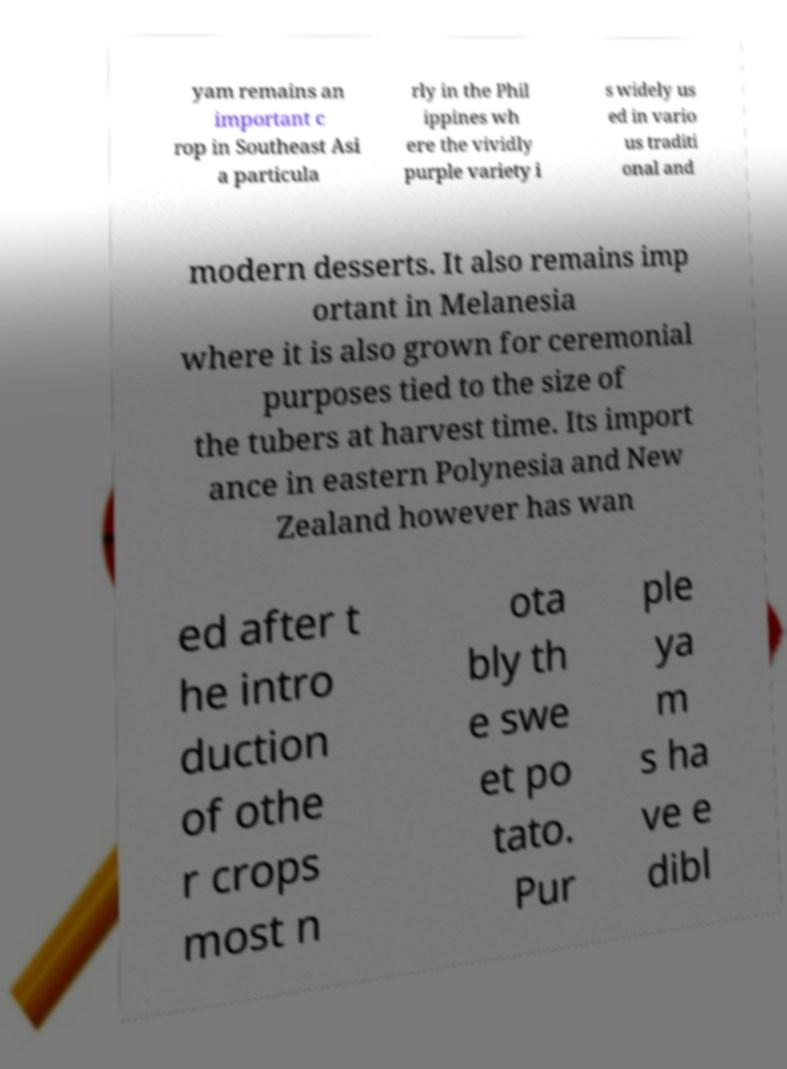Could you extract and type out the text from this image? yam remains an important c rop in Southeast Asi a particula rly in the Phil ippines wh ere the vividly purple variety i s widely us ed in vario us traditi onal and modern desserts. It also remains imp ortant in Melanesia where it is also grown for ceremonial purposes tied to the size of the tubers at harvest time. Its import ance in eastern Polynesia and New Zealand however has wan ed after t he intro duction of othe r crops most n ota bly th e swe et po tato. Pur ple ya m s ha ve e dibl 